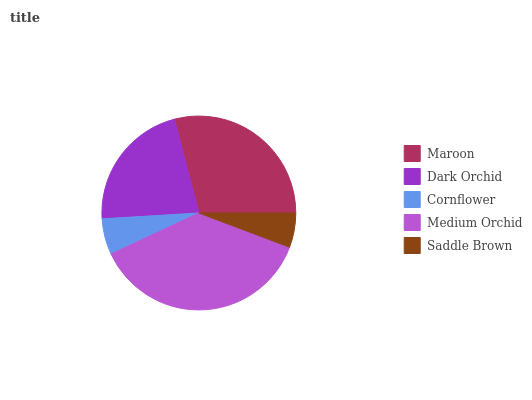Is Saddle Brown the minimum?
Answer yes or no. Yes. Is Medium Orchid the maximum?
Answer yes or no. Yes. Is Dark Orchid the minimum?
Answer yes or no. No. Is Dark Orchid the maximum?
Answer yes or no. No. Is Maroon greater than Dark Orchid?
Answer yes or no. Yes. Is Dark Orchid less than Maroon?
Answer yes or no. Yes. Is Dark Orchid greater than Maroon?
Answer yes or no. No. Is Maroon less than Dark Orchid?
Answer yes or no. No. Is Dark Orchid the high median?
Answer yes or no. Yes. Is Dark Orchid the low median?
Answer yes or no. Yes. Is Cornflower the high median?
Answer yes or no. No. Is Saddle Brown the low median?
Answer yes or no. No. 